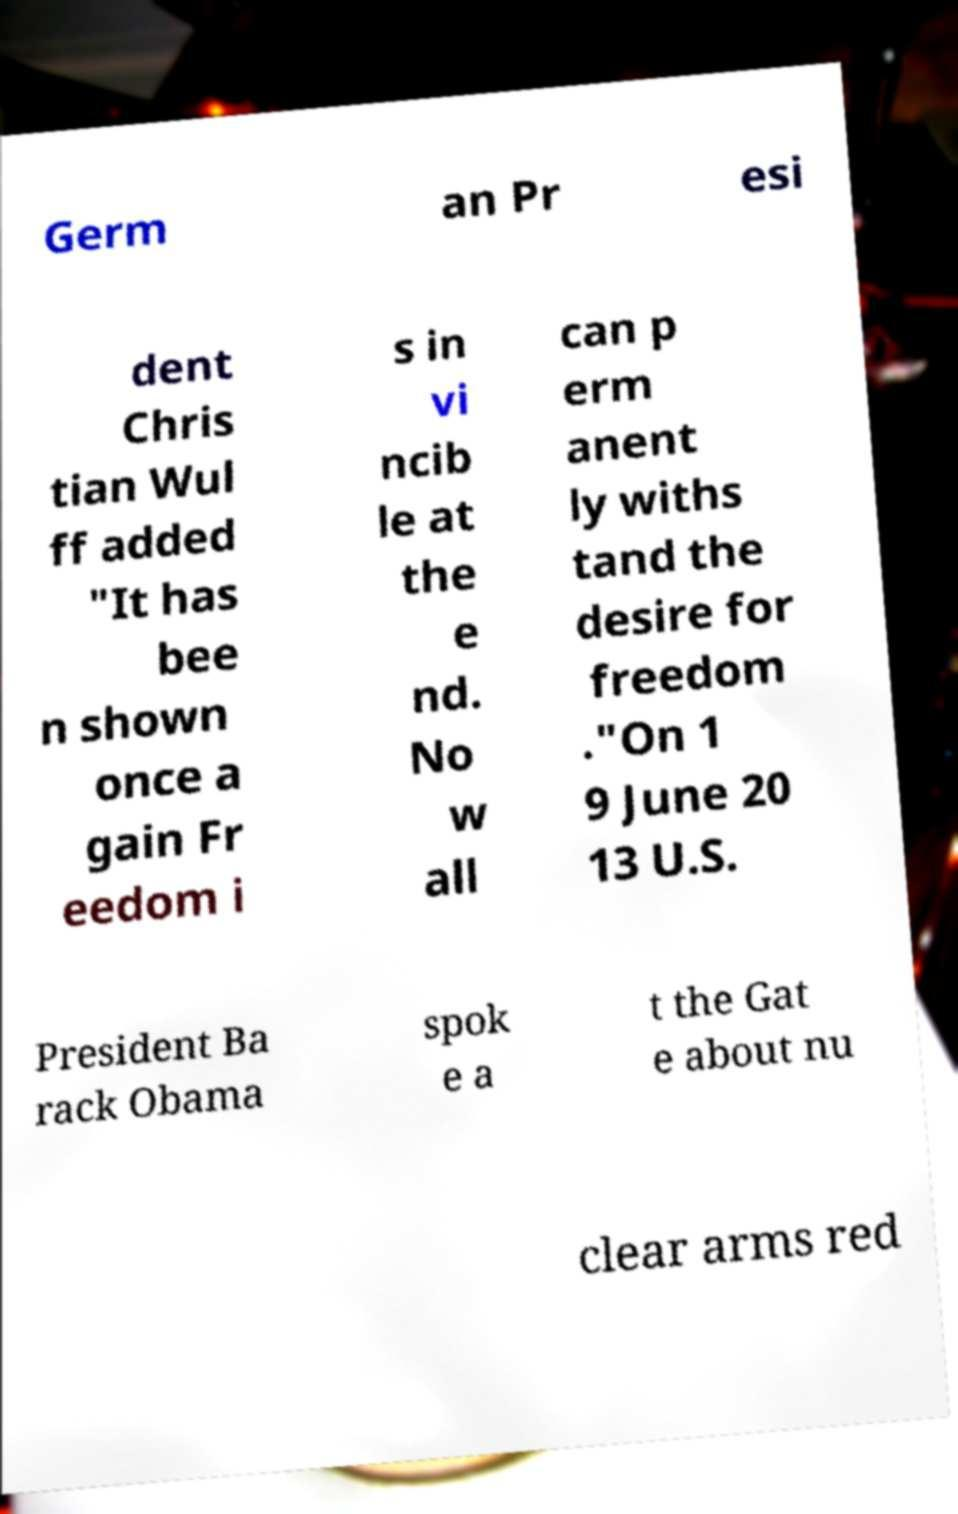Could you assist in decoding the text presented in this image and type it out clearly? Germ an Pr esi dent Chris tian Wul ff added "It has bee n shown once a gain Fr eedom i s in vi ncib le at the e nd. No w all can p erm anent ly withs tand the desire for freedom ."On 1 9 June 20 13 U.S. President Ba rack Obama spok e a t the Gat e about nu clear arms red 